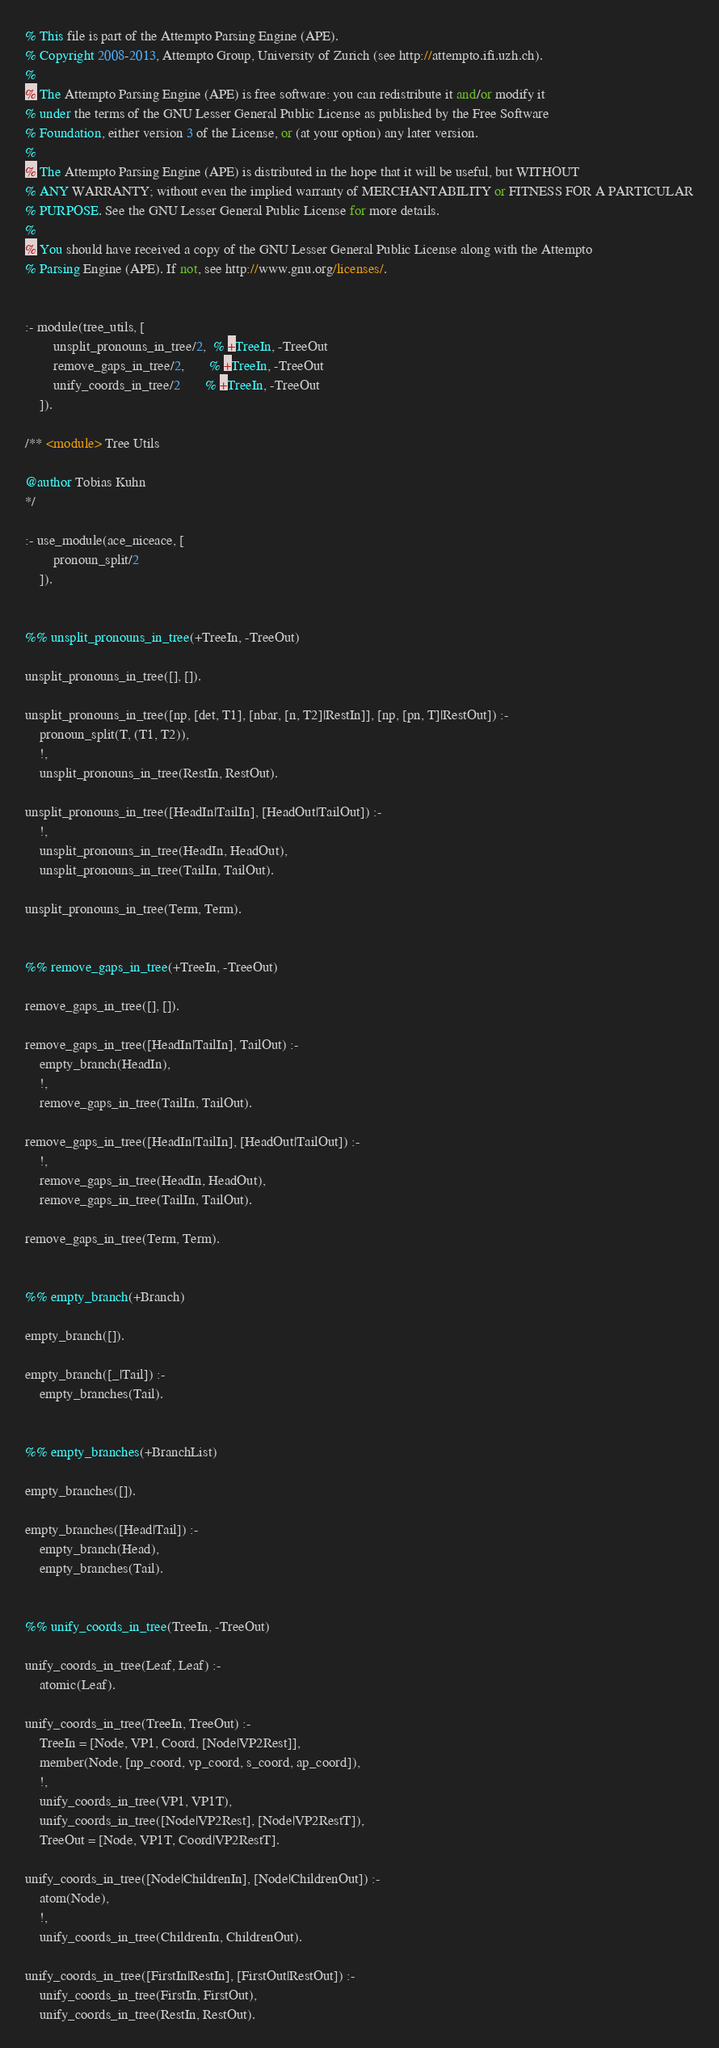Convert code to text. <code><loc_0><loc_0><loc_500><loc_500><_Perl_>% This file is part of the Attempto Parsing Engine (APE).
% Copyright 2008-2013, Attempto Group, University of Zurich (see http://attempto.ifi.uzh.ch).
%
% The Attempto Parsing Engine (APE) is free software: you can redistribute it and/or modify it
% under the terms of the GNU Lesser General Public License as published by the Free Software
% Foundation, either version 3 of the License, or (at your option) any later version.
%
% The Attempto Parsing Engine (APE) is distributed in the hope that it will be useful, but WITHOUT
% ANY WARRANTY; without even the implied warranty of MERCHANTABILITY or FITNESS FOR A PARTICULAR
% PURPOSE. See the GNU Lesser General Public License for more details.
%
% You should have received a copy of the GNU Lesser General Public License along with the Attempto
% Parsing Engine (APE). If not, see http://www.gnu.org/licenses/.


:- module(tree_utils, [
		unsplit_pronouns_in_tree/2,  % +TreeIn, -TreeOut
		remove_gaps_in_tree/2,       % +TreeIn, -TreeOut
		unify_coords_in_tree/2       % +TreeIn, -TreeOut
	]).

/** <module> Tree Utils

@author Tobias Kuhn
*/

:- use_module(ace_niceace, [
		pronoun_split/2
	]).


%% unsplit_pronouns_in_tree(+TreeIn, -TreeOut)

unsplit_pronouns_in_tree([], []).

unsplit_pronouns_in_tree([np, [det, T1], [nbar, [n, T2]|RestIn]], [np, [pn, T]|RestOut]) :-
    pronoun_split(T, (T1, T2)),
    !,
    unsplit_pronouns_in_tree(RestIn, RestOut).

unsplit_pronouns_in_tree([HeadIn|TailIn], [HeadOut|TailOut]) :-
    !,
    unsplit_pronouns_in_tree(HeadIn, HeadOut),
    unsplit_pronouns_in_tree(TailIn, TailOut).

unsplit_pronouns_in_tree(Term, Term).


%% remove_gaps_in_tree(+TreeIn, -TreeOut)

remove_gaps_in_tree([], []).

remove_gaps_in_tree([HeadIn|TailIn], TailOut) :-
    empty_branch(HeadIn),
    !,
    remove_gaps_in_tree(TailIn, TailOut).

remove_gaps_in_tree([HeadIn|TailIn], [HeadOut|TailOut]) :-
    !,
    remove_gaps_in_tree(HeadIn, HeadOut),
    remove_gaps_in_tree(TailIn, TailOut).

remove_gaps_in_tree(Term, Term).


%% empty_branch(+Branch)

empty_branch([]).

empty_branch([_|Tail]) :-
    empty_branches(Tail).


%% empty_branches(+BranchList)

empty_branches([]).

empty_branches([Head|Tail]) :-
    empty_branch(Head),
    empty_branches(Tail).


%% unify_coords_in_tree(TreeIn, -TreeOut)

unify_coords_in_tree(Leaf, Leaf) :-
    atomic(Leaf).

unify_coords_in_tree(TreeIn, TreeOut) :-
    TreeIn = [Node, VP1, Coord, [Node|VP2Rest]],
    member(Node, [np_coord, vp_coord, s_coord, ap_coord]),
    !,
    unify_coords_in_tree(VP1, VP1T),
    unify_coords_in_tree([Node|VP2Rest], [Node|VP2RestT]),
    TreeOut = [Node, VP1T, Coord|VP2RestT].

unify_coords_in_tree([Node|ChildrenIn], [Node|ChildrenOut]) :-
    atom(Node),
    !,
    unify_coords_in_tree(ChildrenIn, ChildrenOut).

unify_coords_in_tree([FirstIn|RestIn], [FirstOut|RestOut]) :-
    unify_coords_in_tree(FirstIn, FirstOut),
    unify_coords_in_tree(RestIn, RestOut).
</code> 